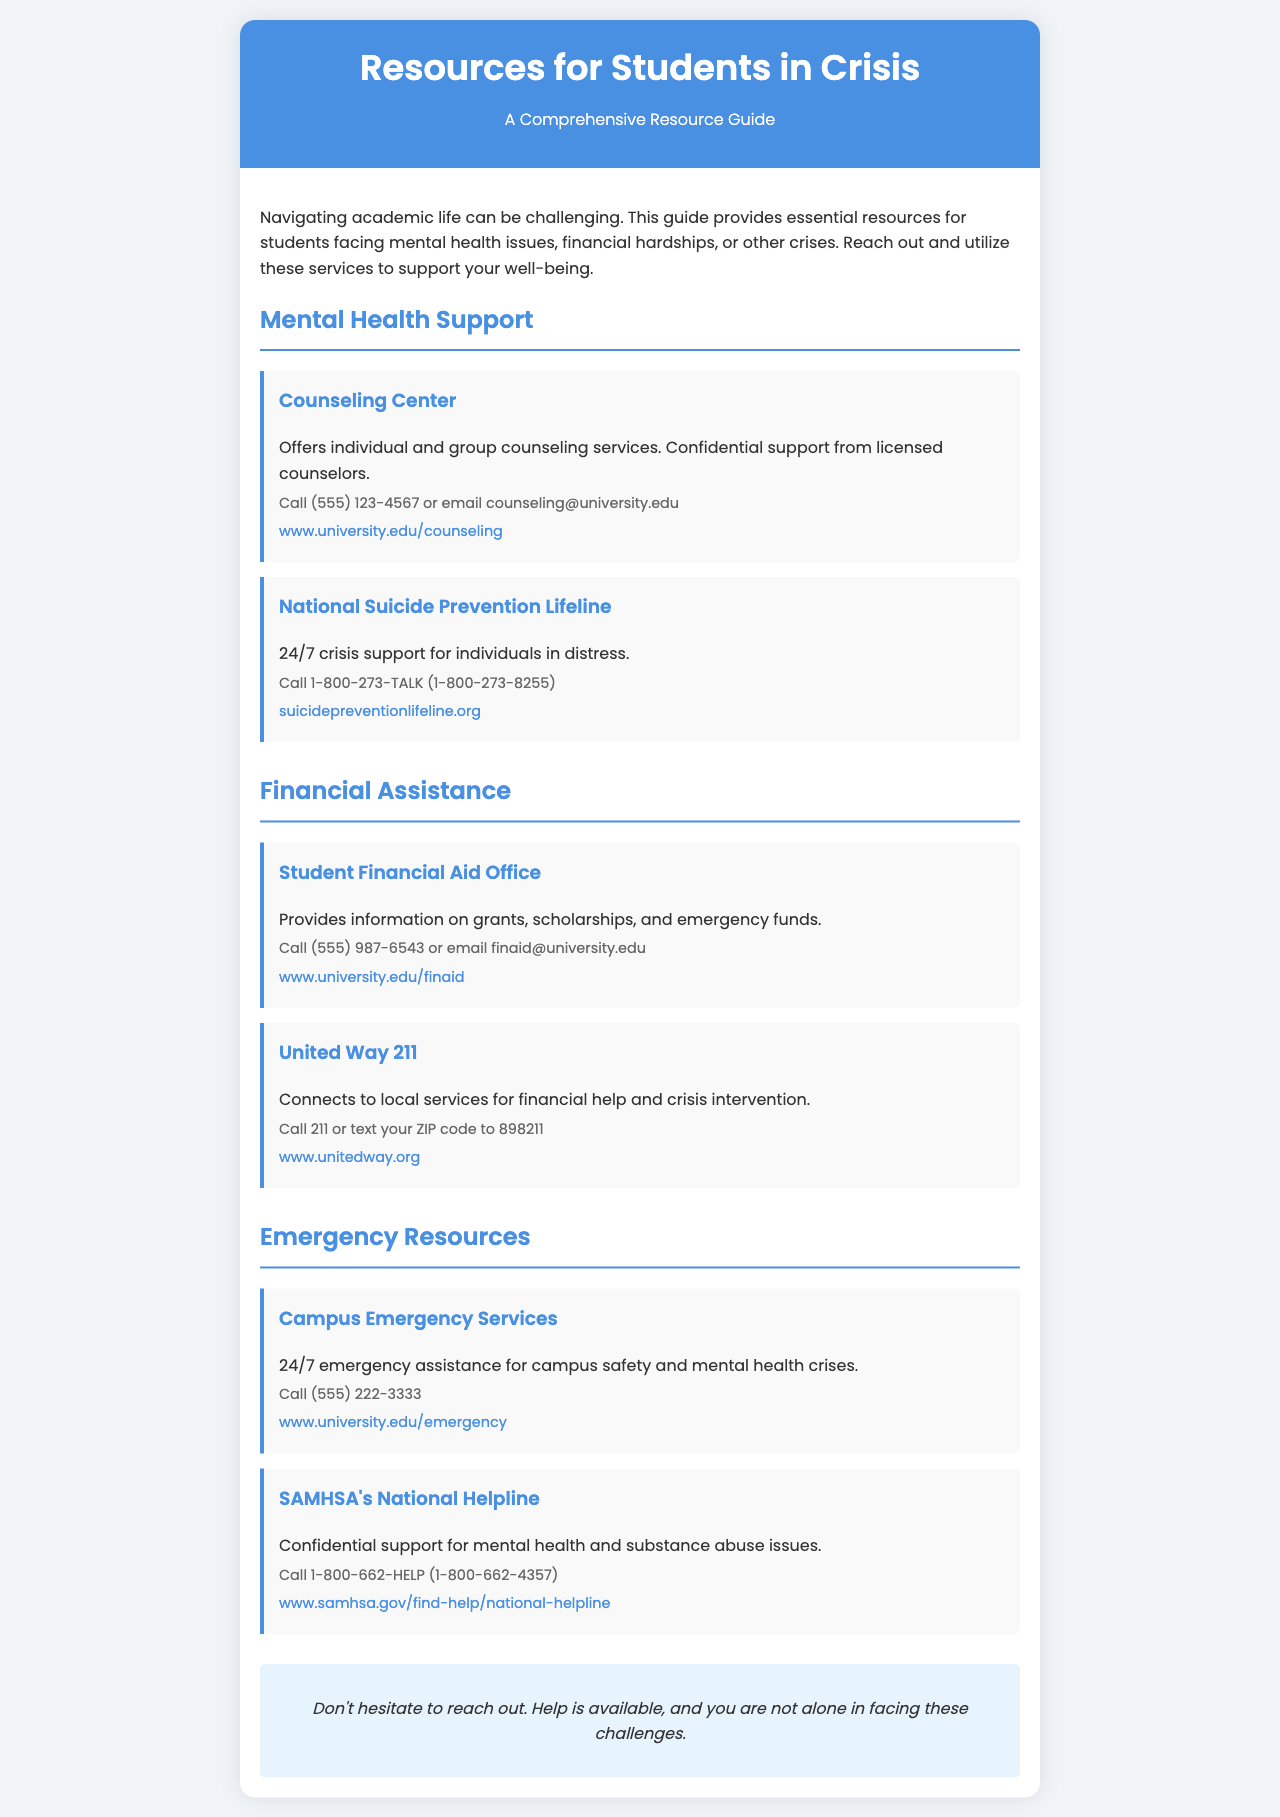What is the title of the brochure? The title is prominently displayed at the top of the document, which is "Resources for Students in Crisis."
Answer: Resources for Students in Crisis What is the contact number for the Counseling Center? The document provides a specific phone number for the Counseling Center under the Mental Health Support section.
Answer: (555) 123-4567 What service does United Way 211 provide? The document states that United Way 211 connects students to local services for financial help and crisis intervention.
Answer: Financial help and crisis intervention Which organization offers 24/7 crisis support? The document mentions the National Suicide Prevention Lifeline as available 24/7 for crisis support.
Answer: National Suicide Prevention Lifeline What is the email address for the Student Financial Aid Office? The brochure lists an email address for contacting the Student Financial Aid Office in the Financial Assistance section.
Answer: finaid@university.edu How many resources are listed under the Emergency Resources section? By counting the resource entries, you can find the number of resources provided in the Emergency Resources section.
Answer: 2 What type of support does SAMHSA's National Helpline offer? The specific support type offered by SAMHSA's National Helpline is mentioned in the brochure under the Emergency Resources section.
Answer: Confidential support for mental health and substance abuse What should students do if they need help according to the brochure? The final note in the document encourages students to take action if they are facing challenges.
Answer: Reach out 